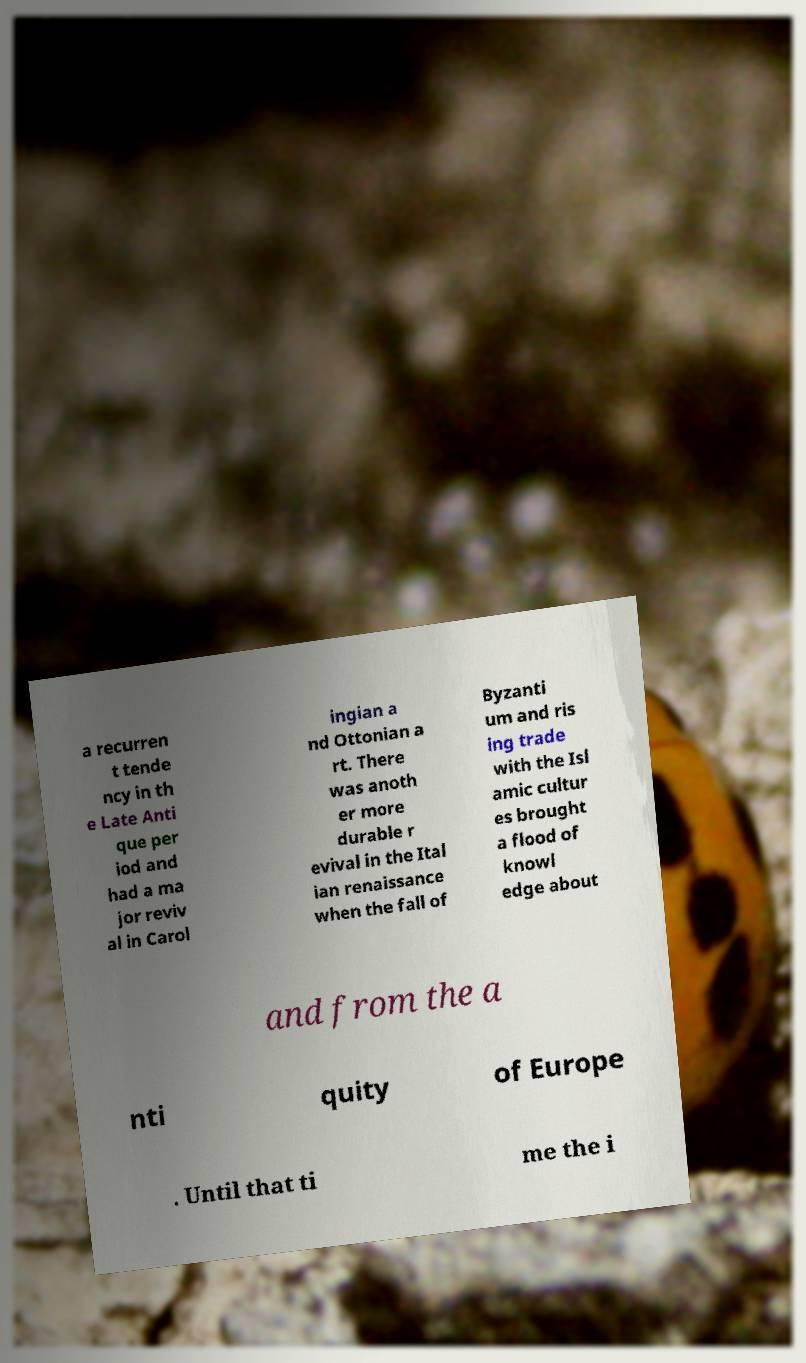I need the written content from this picture converted into text. Can you do that? a recurren t tende ncy in th e Late Anti que per iod and had a ma jor reviv al in Carol ingian a nd Ottonian a rt. There was anoth er more durable r evival in the Ital ian renaissance when the fall of Byzanti um and ris ing trade with the Isl amic cultur es brought a flood of knowl edge about and from the a nti quity of Europe . Until that ti me the i 